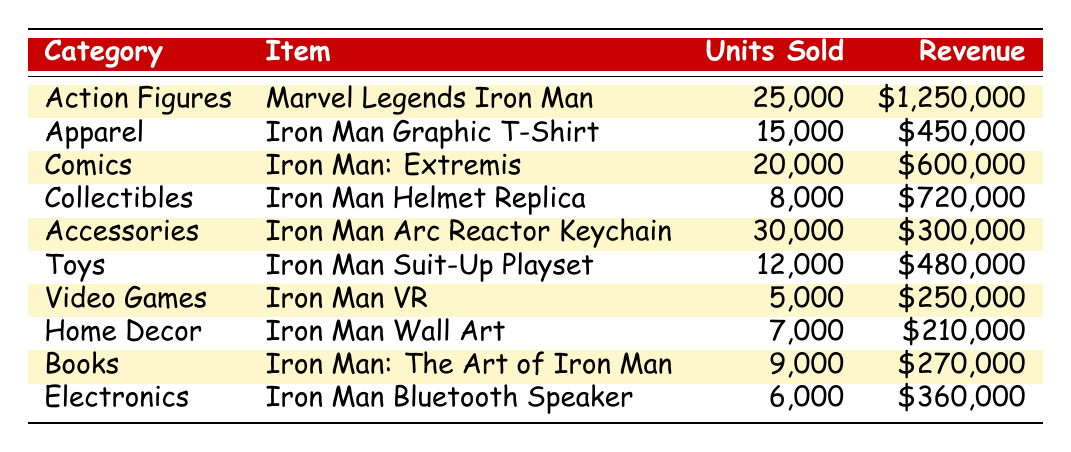What is the item with the highest revenue? Based on the table, the item that generates the highest revenue is the Marvel Legends Iron Man from the Action Figures category, with a revenue of $1,250,000.
Answer: Marvel Legends Iron Man How many units of Iron Man Graphic T-Shirts were sold? The table lists that 15,000 units of the Iron Man Graphic T-Shirt in the Apparel category were sold.
Answer: 15,000 Which category has the least number of units sold? By examining the units sold in each category, Video Games has the least with only 5,000 units sold.
Answer: Video Games What is the total revenue generated from the Comics category? The table indicates that the Iron Man: Extremis comic generated $600,000 in revenue.
Answer: $600,000 Which category sold more units: Accessories or Toys? Accessories sold 30,000 units (Iron Man Arc Reactor Keychain) while Toys sold 12,000 units (Iron Man Suit-Up Playset). Hence, Accessories sold more units.
Answer: Accessories What is the average number of units sold across all categories? First, sum the units sold: 25,000 + 15,000 + 20,000 + 8,000 + 30,000 + 12,000 + 5,000 + 7,000 + 9,000 + 6,000 =  137,000. Then, divide by the number of categories (10): 137,000 / 10 = 13,700.
Answer: 13,700 Is the revenue from the Iron Man Helmet Replica greater than that from the Iron Man Wall Art? The revenue from the Iron Man Helmet Replica is $720,000, while the Iron Man Wall Art brings in $210,000. Since $720,000 is greater than $210,000, the statement is true.
Answer: Yes What is the total number of units sold for Collectibles and Apparel combined? For Collectibles, 8,000 units were sold for the Iron Man Helmet Replica, and for Apparel, 15,000 units were sold for the Iron Man Graphic T-Shirt. Summing these gives 8,000 + 15,000 = 23,000 units sold combined.
Answer: 23,000 Which item has the highest units sold and what is the figure? The item with the highest units sold is the Iron Man Arc Reactor Keychain in the Accessories category, with 30,000 units sold.
Answer: Iron Man Arc Reactor Keychain; 30,000 What is the difference in revenue between the Action Figures category and the Electronics category? Action Figures generated $1,250,000 in revenue, while Electronics generated $360,000. The difference is $1,250,000 - $360,000 = $890,000.
Answer: $890,000 How many more units of Apparel were sold than Home Decor? Apparel had 15,000 units sold and Home Decor had 7,000 units sold. The difference is 15,000 - 7,000 = 8,000 units.
Answer: 8,000 